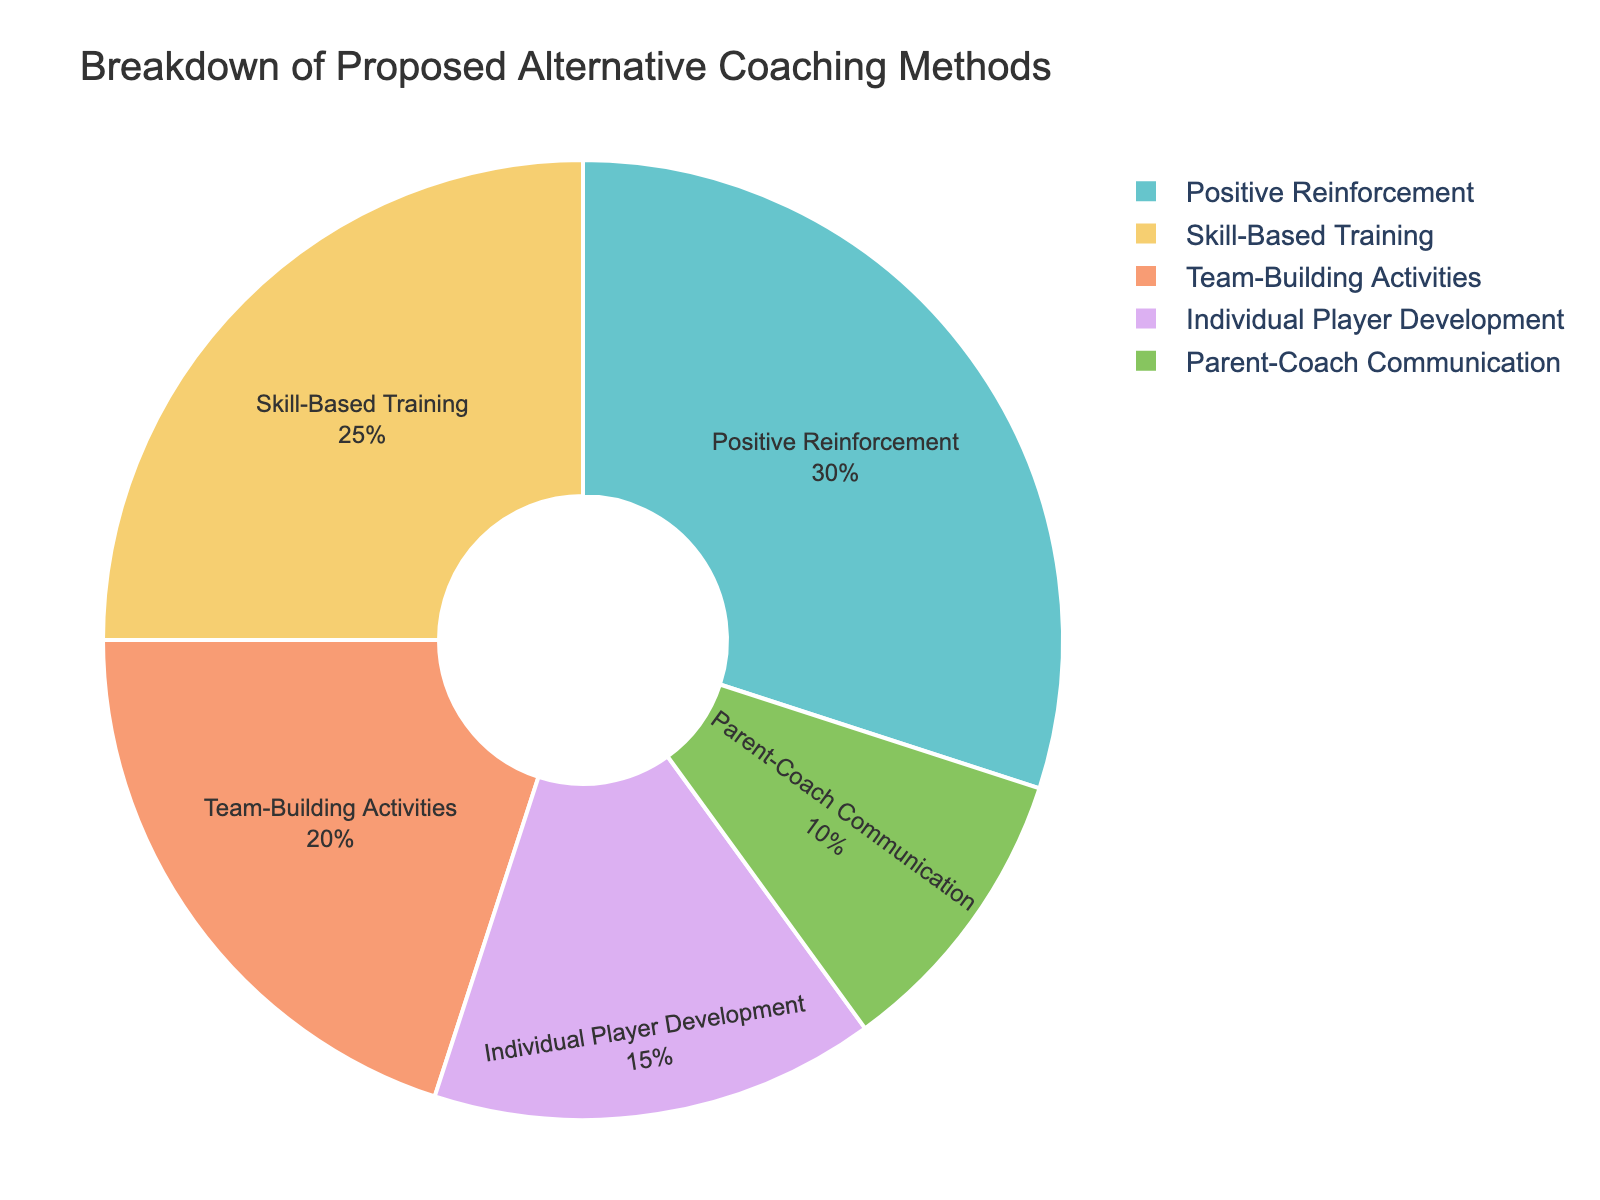Which method has the largest percentage? To determine the largest percentage, look for the section of the pie chart that represents the biggest slice. Positive Reinforcement holds the largest percentage at 30%.
Answer: Positive Reinforcement What is the combined percentage of Skill-Based Training and Team-Building Activities? First, locate Skill-Based Training (25%) and Team-Building Activities (20%) on the chart. Add these two percentages together: 25% + 20% = 45%.
Answer: 45% Which method accounts for the smallest proportion in the chart? Identify the smallest slice in the pie chart. Parent-Coach Communication, at 10%, is the smallest.
Answer: Parent-Coach Communication How much more percentage does Positive Reinforcement have than Individual Player Development? Find the percentages for Positive Reinforcement (30%) and Individual Player Development (15%). Subtract the smaller from the larger: 30% - 15% = 15%.
Answer: 15% What is the average percentage of all methods combined? First, sum up all percentages: 30% + 25% + 20% + 15% + 10% = 100%. Since there are 5 methods, the average is 100% / 5 = 20%.
Answer: 20% Are Skill-Based Training and Team-Building Activities together more significant than Positive Reinforcement alone? Calculate the combined percentage of Skill-Based Training and Team-Building Activities: 25% + 20% = 45%. Compare this to Positive Reinforcement (30%). 45% is indeed greater than 30%.
Answer: Yes Which methods together constitute half of the total distribution? We need to find methods that add up to 50%. Start combining from the largest: Positive Reinforcement (30%) and Skill-Based Training (25%). These two sum up to 55%, which is more than half. Next largest, Team-Building (20%) combined with Positive Reinforcement (30%) also exceeds 50%. Therefore, no single set of methods exactly sums to 50%.
Answer: None What percentage of proposed methods is centered around group activities? (Consider Positive Reinforcement and Team-Building Activities) First, find the percentages of Positive Reinforcement (30%) and Team-Building Activities (20%). Then, sum these two: 30% + 20% = 50%.
Answer: 50% Compare the combined percentages of individual and group-focused training methods. (Consider Individual Player Development as individual-focused and the rest as group-focused) Individual-focused: Individual Player Development (15%). Group-focused: Positive Reinforcement (30%) + Skill-Based Training (25%) + Team-Building Activities (20%) + Parent-Coach Communication (10%) = 85%. Group-focused is 85%, which is higher than individual-focused 15%.
Answer: Group-focused (85%) 